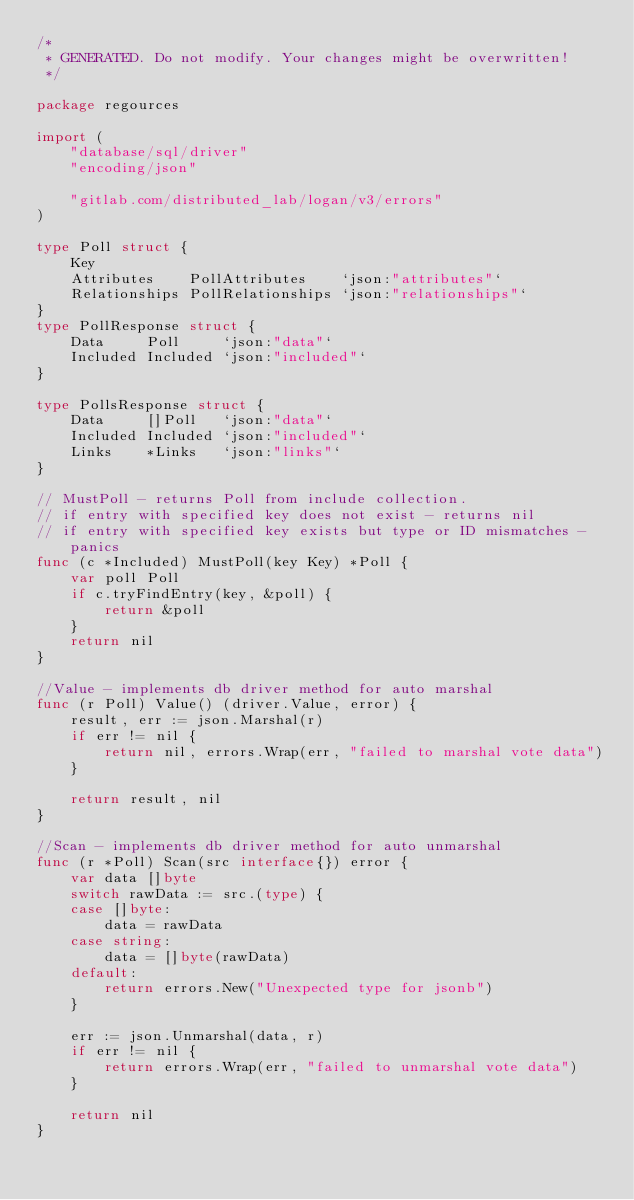<code> <loc_0><loc_0><loc_500><loc_500><_Go_>/*
 * GENERATED. Do not modify. Your changes might be overwritten!
 */

package regources

import (
	"database/sql/driver"
	"encoding/json"

	"gitlab.com/distributed_lab/logan/v3/errors"
)

type Poll struct {
	Key
	Attributes    PollAttributes    `json:"attributes"`
	Relationships PollRelationships `json:"relationships"`
}
type PollResponse struct {
	Data     Poll     `json:"data"`
	Included Included `json:"included"`
}

type PollsResponse struct {
	Data     []Poll   `json:"data"`
	Included Included `json:"included"`
	Links    *Links   `json:"links"`
}

// MustPoll - returns Poll from include collection.
// if entry with specified key does not exist - returns nil
// if entry with specified key exists but type or ID mismatches - panics
func (c *Included) MustPoll(key Key) *Poll {
	var poll Poll
	if c.tryFindEntry(key, &poll) {
		return &poll
	}
	return nil
}

//Value - implements db driver method for auto marshal
func (r Poll) Value() (driver.Value, error) {
	result, err := json.Marshal(r)
	if err != nil {
		return nil, errors.Wrap(err, "failed to marshal vote data")
	}

	return result, nil
}

//Scan - implements db driver method for auto unmarshal
func (r *Poll) Scan(src interface{}) error {
	var data []byte
	switch rawData := src.(type) {
	case []byte:
		data = rawData
	case string:
		data = []byte(rawData)
	default:
		return errors.New("Unexpected type for jsonb")
	}

	err := json.Unmarshal(data, r)
	if err != nil {
		return errors.Wrap(err, "failed to unmarshal vote data")
	}

	return nil
}
</code> 